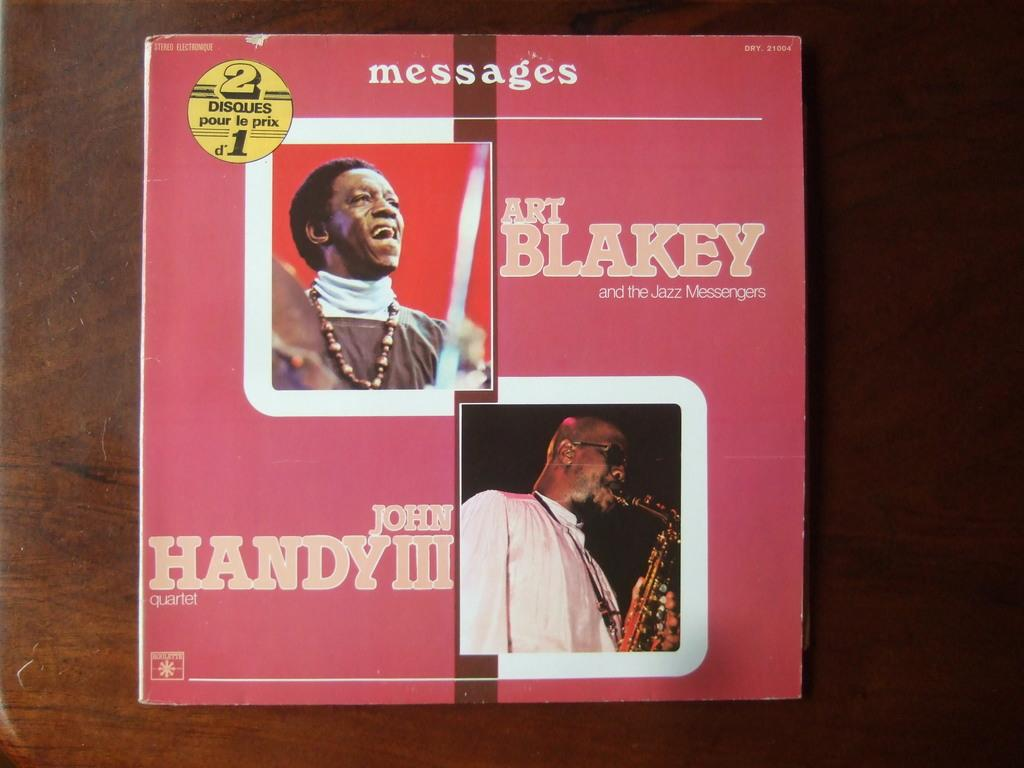Provide a one-sentence caption for the provided image. Art Blakey and John Handy are listed on this double album cover. 